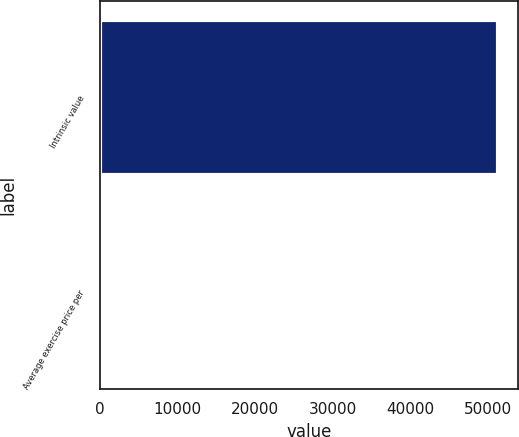Convert chart to OTSL. <chart><loc_0><loc_0><loc_500><loc_500><bar_chart><fcel>Intrinsic value<fcel>Average exercise price per<nl><fcel>51408<fcel>30.06<nl></chart> 